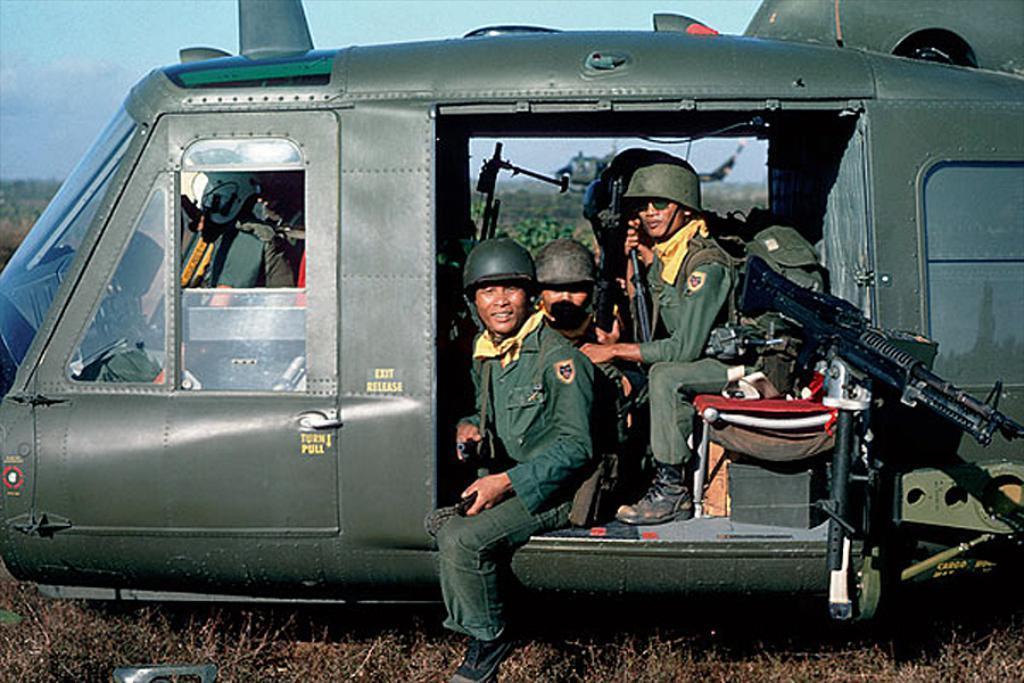In one or two sentences, can you explain what this image depicts? In this image in the center there is one vehicle, in that vehicle there are some people who are sitting and they are holding guns. And in that vehicle there are some other objects, at the bottom there is grass and in the background there are some trees and a helicopter. 